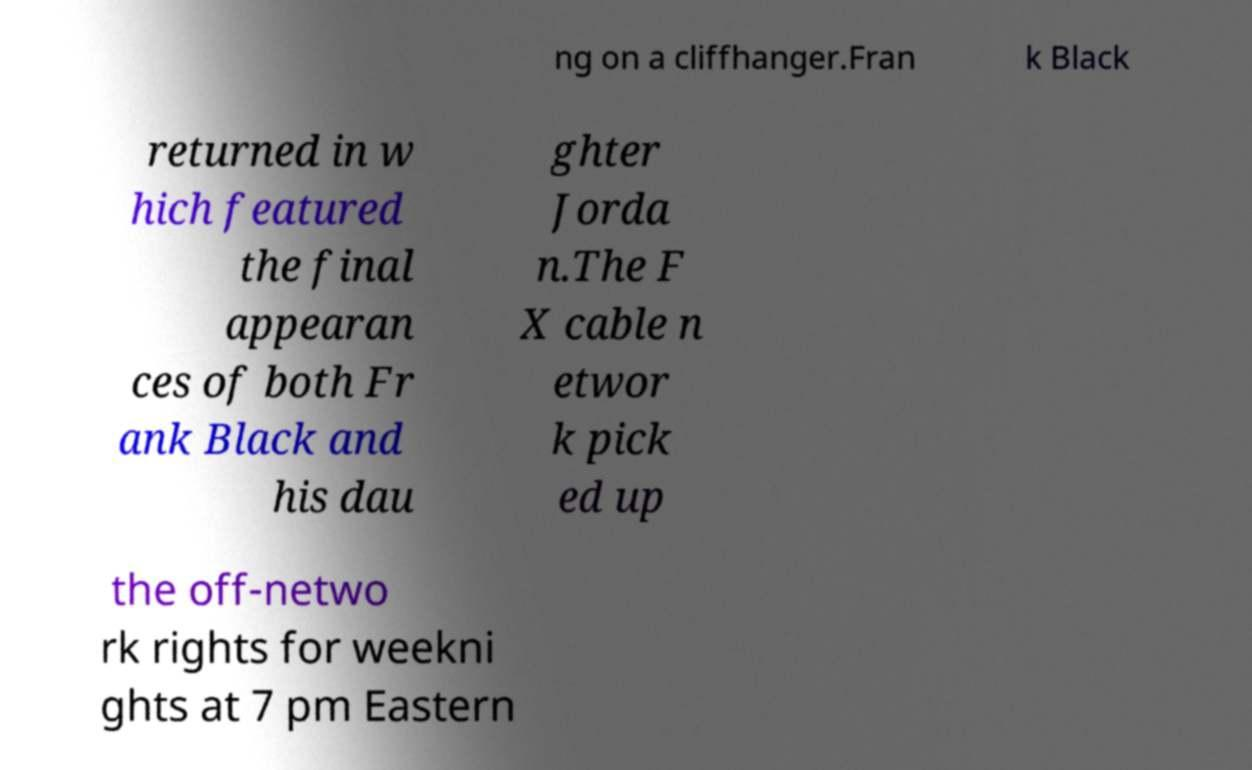Please identify and transcribe the text found in this image. ng on a cliffhanger.Fran k Black returned in w hich featured the final appearan ces of both Fr ank Black and his dau ghter Jorda n.The F X cable n etwor k pick ed up the off-netwo rk rights for weekni ghts at 7 pm Eastern 